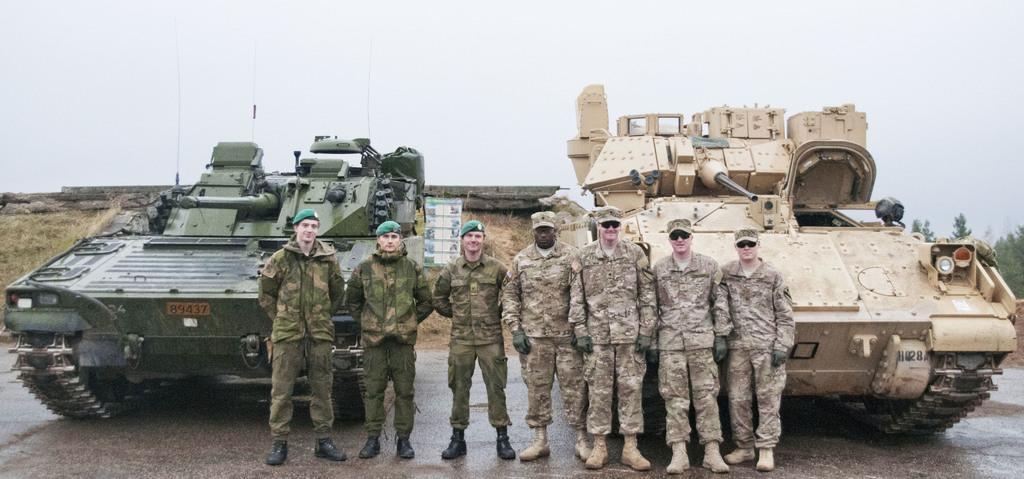Describe this image in one or two sentences. In this image I can see few people are standing and wearing military dress. Back I can see vehicles which is in cream and green color. I can see wall,dry grass and trees. The sky is in white color. 